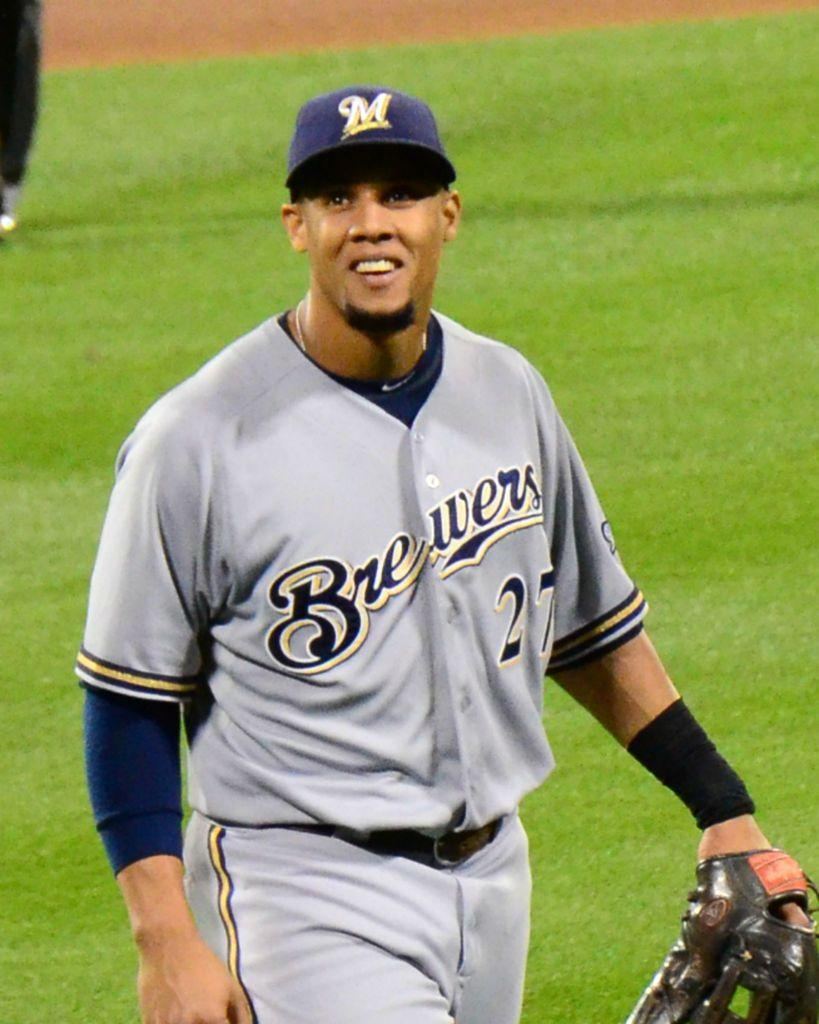Provide a one-sentence caption for the provided image. Number 27 for the Brewers is right handed. 